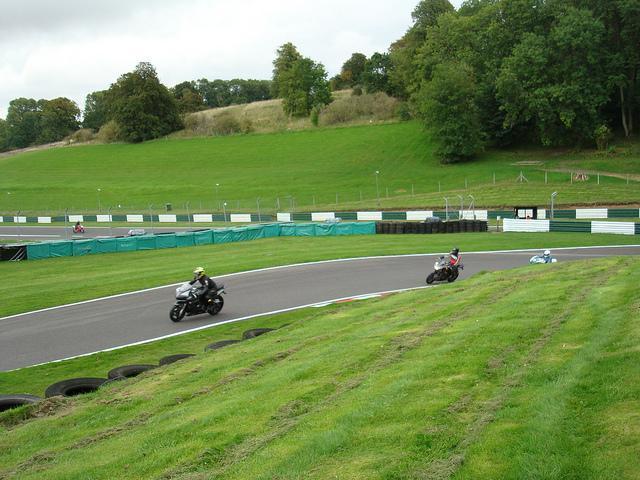How many tusks does the elephant have?
Give a very brief answer. 0. 